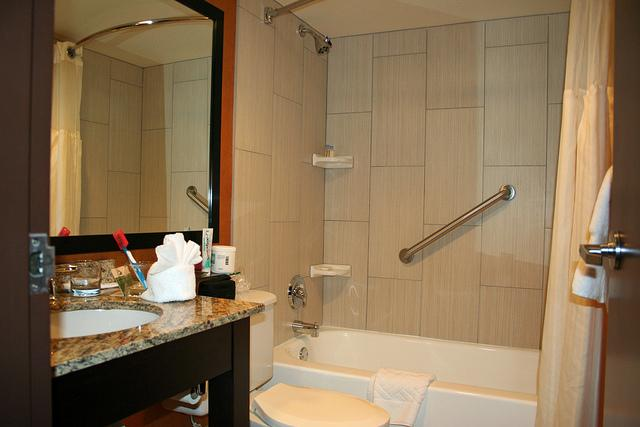What is the blue/white/red item by the sink? toothbrush 